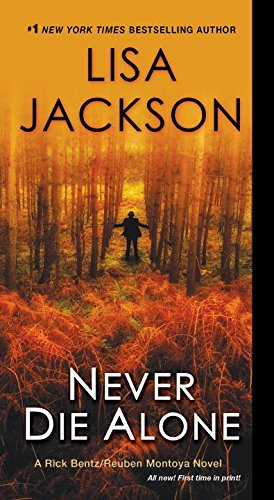What does the setting on the cover imply about the storyline? The setting on the cover, featuring a dense forest and a lone individual, implies a narrative filled with isolation and possibly the exploration of secrets hidden within the woods. This backdrop can be indicative of the main character's journey into unknown dangers or deep personal revelations. 